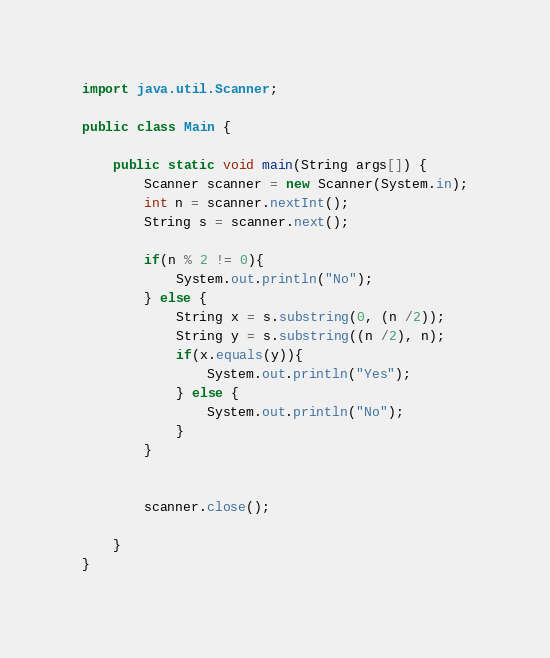<code> <loc_0><loc_0><loc_500><loc_500><_Java_>import java.util.Scanner;

public class Main {

    public static void main(String args[]) {
        Scanner scanner = new Scanner(System.in);
        int n = scanner.nextInt();
        String s = scanner.next();

        if(n % 2 != 0){
            System.out.println("No");
        } else {
            String x = s.substring(0, (n /2));
            String y = s.substring((n /2), n);
            if(x.equals(y)){
                System.out.println("Yes");
            } else {
                System.out.println("No");
            }
        }


        scanner.close();

    }
}</code> 